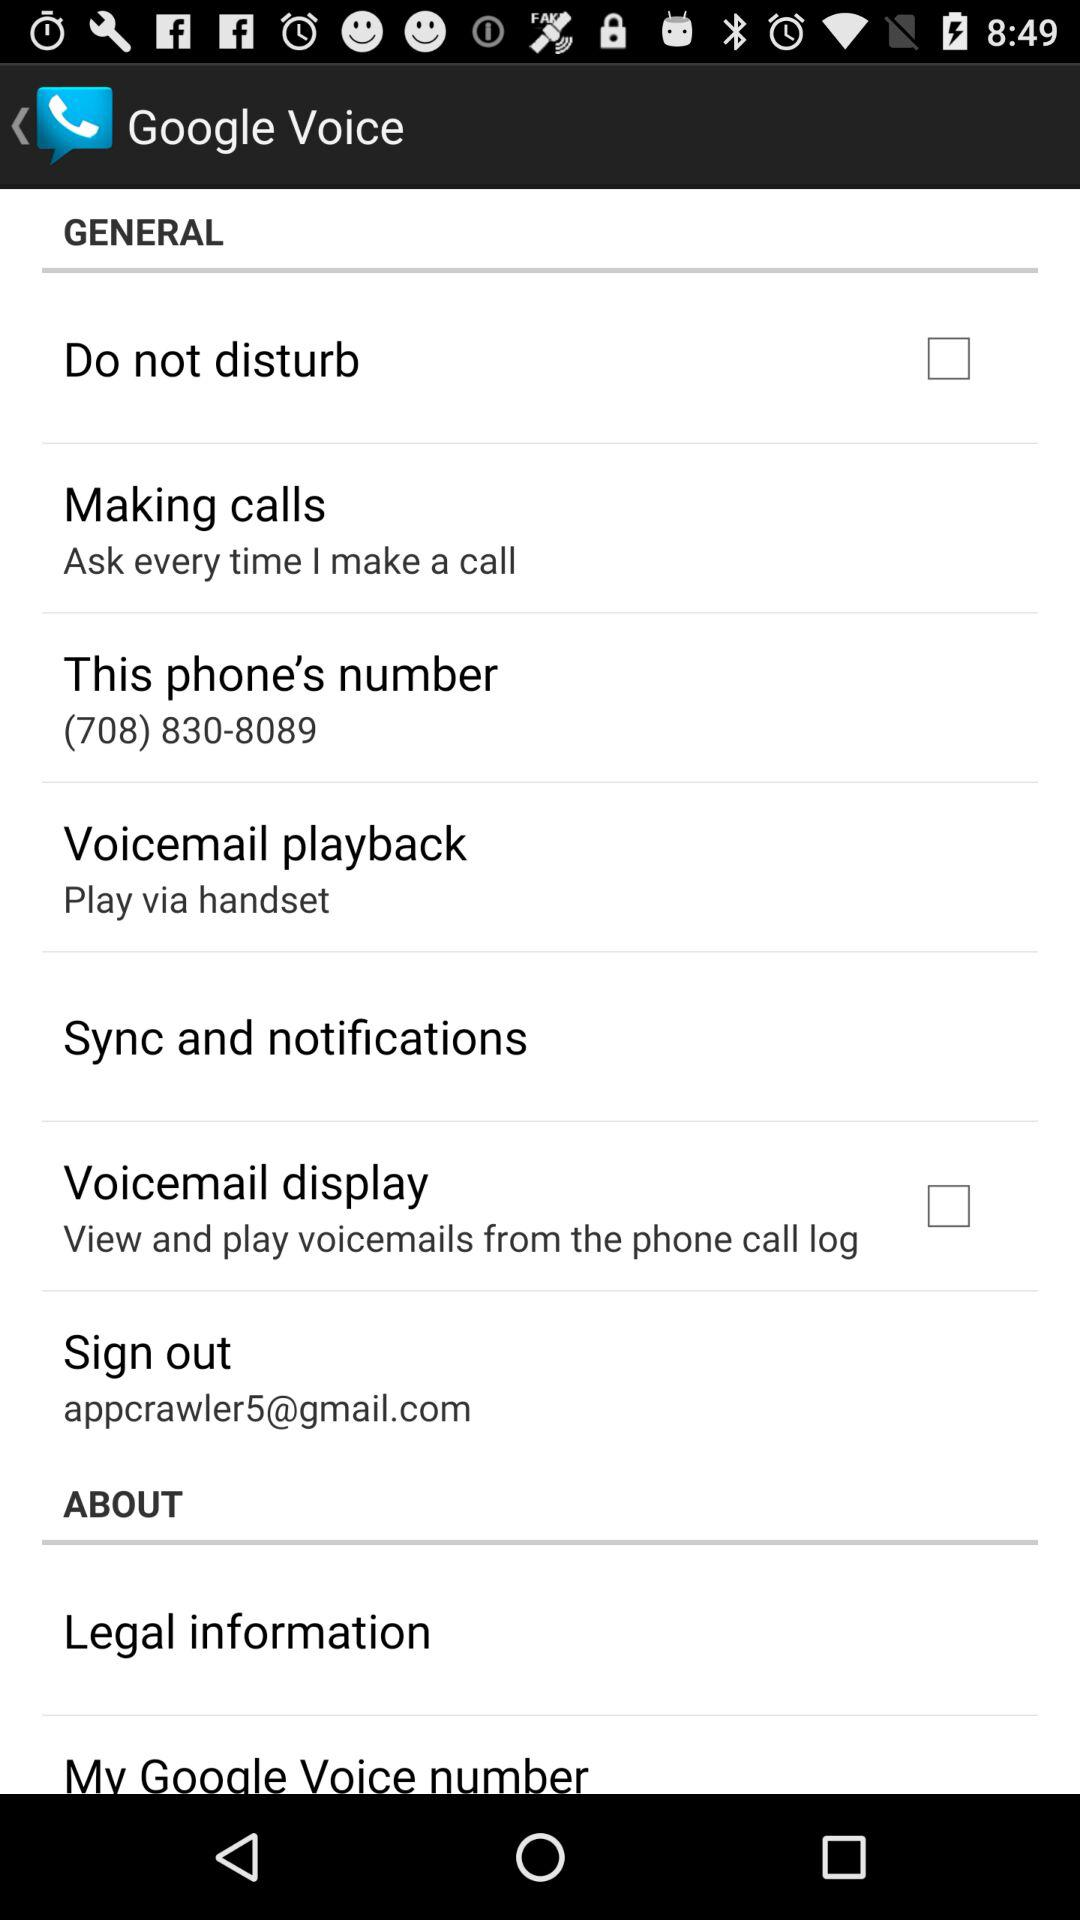What mail ID will be signed out? The mail ID is appcrawler5@gmail.com. 